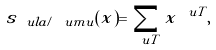Convert formula to latex. <formula><loc_0><loc_0><loc_500><loc_500>s _ { \ u l a / \ u m u } ( x ) = \sum _ { \ u T } x ^ { \ u T } ,</formula> 